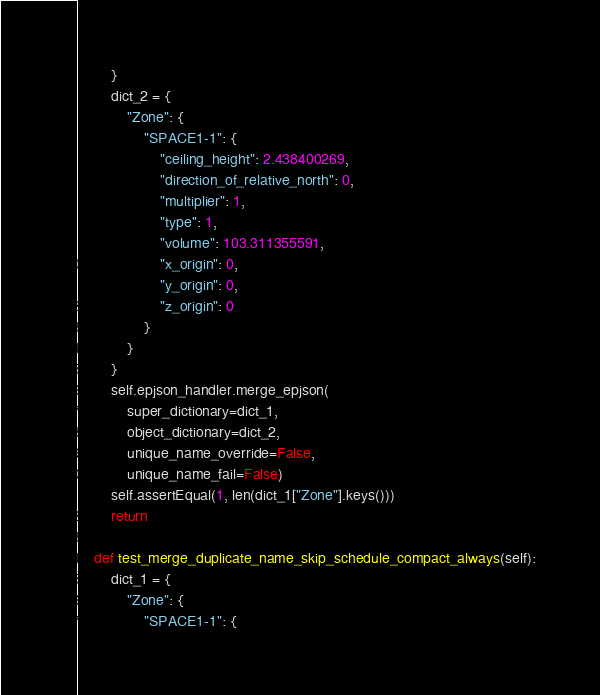Convert code to text. <code><loc_0><loc_0><loc_500><loc_500><_Python_>        }
        dict_2 = {
            "Zone": {
                "SPACE1-1": {
                    "ceiling_height": 2.438400269,
                    "direction_of_relative_north": 0,
                    "multiplier": 1,
                    "type": 1,
                    "volume": 103.311355591,
                    "x_origin": 0,
                    "y_origin": 0,
                    "z_origin": 0
                }
            }
        }
        self.epjson_handler.merge_epjson(
            super_dictionary=dict_1,
            object_dictionary=dict_2,
            unique_name_override=False,
            unique_name_fail=False)
        self.assertEqual(1, len(dict_1["Zone"].keys()))
        return

    def test_merge_duplicate_name_skip_schedule_compact_always(self):
        dict_1 = {
            "Zone": {
                "SPACE1-1": {</code> 